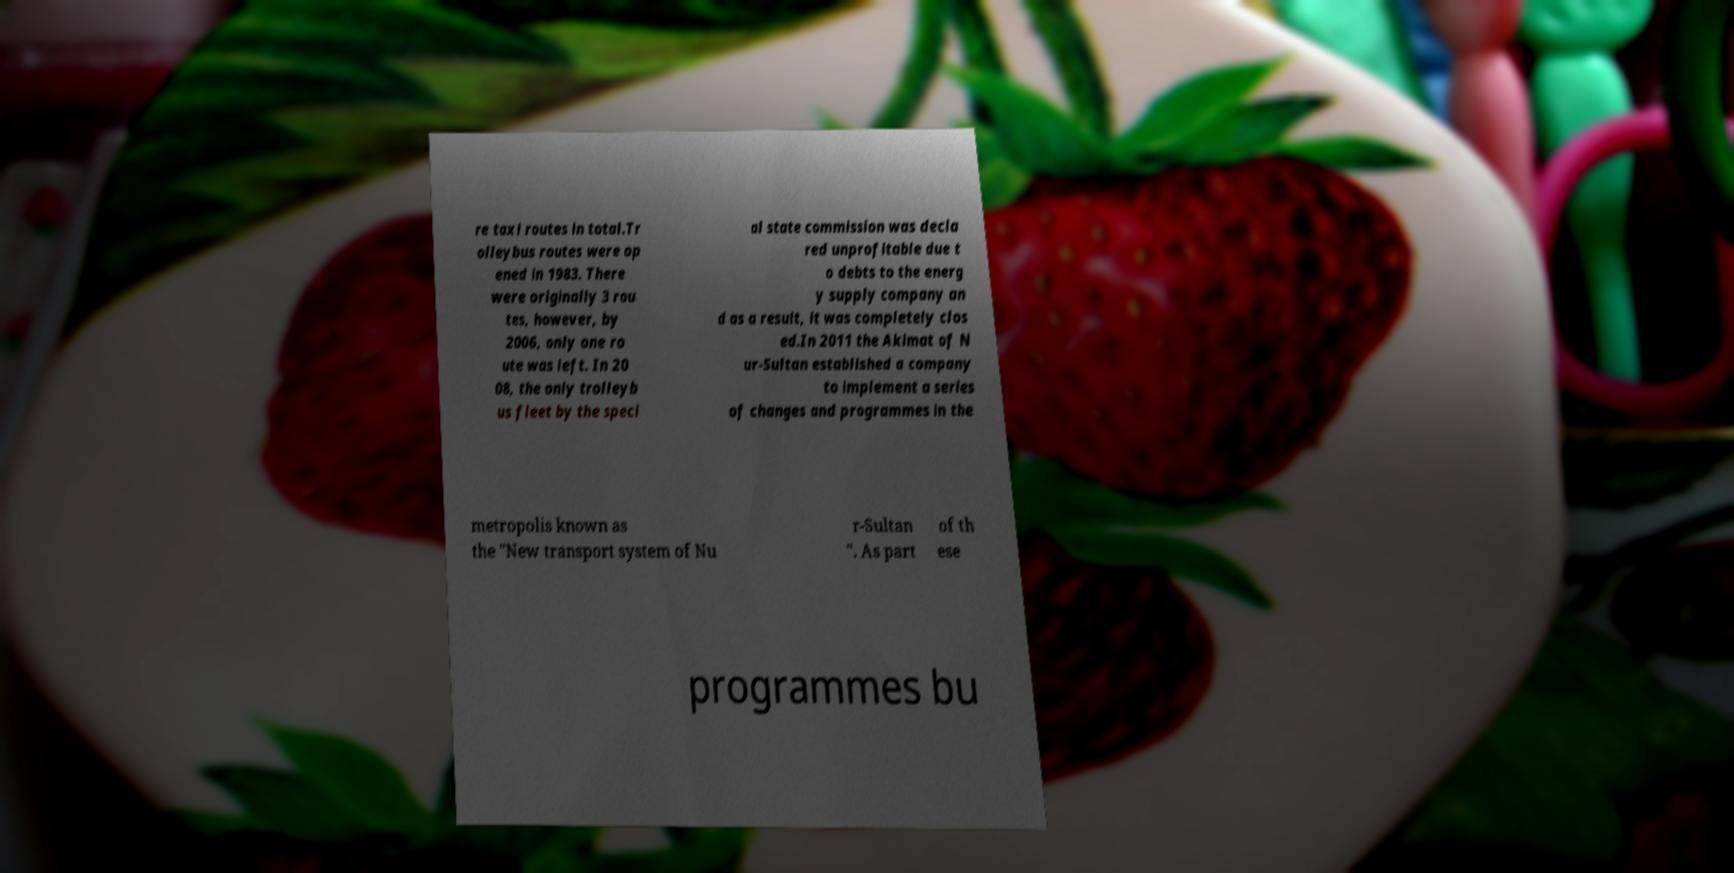I need the written content from this picture converted into text. Can you do that? re taxi routes in total.Tr olleybus routes were op ened in 1983. There were originally 3 rou tes, however, by 2006, only one ro ute was left. In 20 08, the only trolleyb us fleet by the speci al state commission was decla red unprofitable due t o debts to the energ y supply company an d as a result, it was completely clos ed.In 2011 the Akimat of N ur-Sultan established a company to implement a series of changes and programmes in the metropolis known as the "New transport system of Nu r-Sultan ". As part of th ese programmes bu 